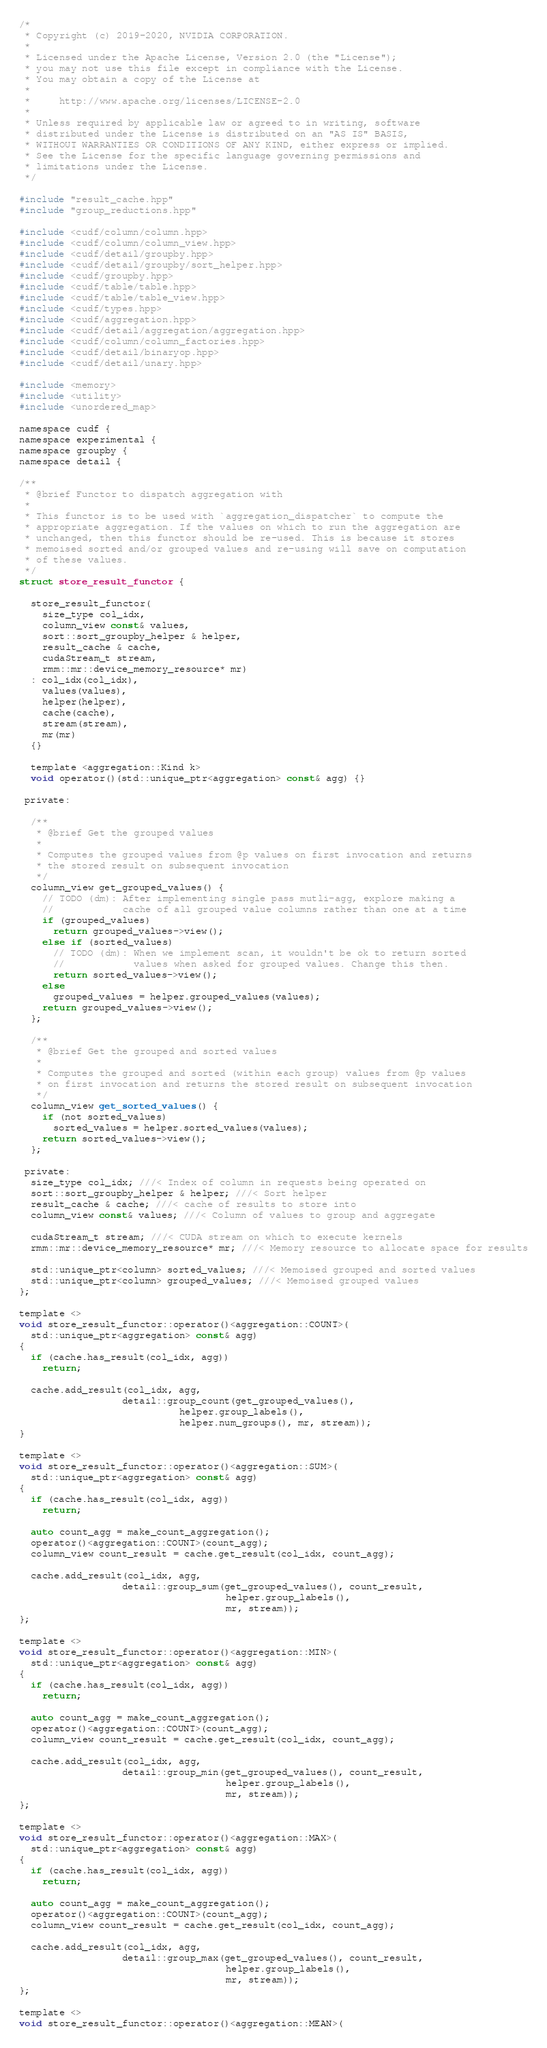Convert code to text. <code><loc_0><loc_0><loc_500><loc_500><_Cuda_>/*
 * Copyright (c) 2019-2020, NVIDIA CORPORATION.
 *
 * Licensed under the Apache License, Version 2.0 (the "License");
 * you may not use this file except in compliance with the License.
 * You may obtain a copy of the License at
 *
 *     http://www.apache.org/licenses/LICENSE-2.0
 *
 * Unless required by applicable law or agreed to in writing, software
 * distributed under the License is distributed on an "AS IS" BASIS,
 * WITHOUT WARRANTIES OR CONDITIONS OF ANY KIND, either express or implied.
 * See the License for the specific language governing permissions and
 * limitations under the License.
 */

#include "result_cache.hpp"
#include "group_reductions.hpp"

#include <cudf/column/column.hpp>
#include <cudf/column/column_view.hpp>
#include <cudf/detail/groupby.hpp>
#include <cudf/detail/groupby/sort_helper.hpp>
#include <cudf/groupby.hpp>
#include <cudf/table/table.hpp>
#include <cudf/table/table_view.hpp>
#include <cudf/types.hpp>
#include <cudf/aggregation.hpp>
#include <cudf/detail/aggregation/aggregation.hpp>
#include <cudf/column/column_factories.hpp>
#include <cudf/detail/binaryop.hpp>
#include <cudf/detail/unary.hpp>

#include <memory>
#include <utility>
#include <unordered_map>

namespace cudf {
namespace experimental {
namespace groupby {
namespace detail {

/**
 * @brief Functor to dispatch aggregation with
 * 
 * This functor is to be used with `aggregation_dispatcher` to compute the
 * appropriate aggregation. If the values on which to run the aggregation are
 * unchanged, then this functor should be re-used. This is because it stores
 * memoised sorted and/or grouped values and re-using will save on computation
 * of these values.
 */
struct store_result_functor {

  store_result_functor(
    size_type col_idx,
    column_view const& values,
    sort::sort_groupby_helper & helper,
    result_cache & cache,
    cudaStream_t stream,
    rmm::mr::device_memory_resource* mr)
  : col_idx(col_idx),
    values(values),
    helper(helper),
    cache(cache),
    stream(stream),
    mr(mr)
  {}

  template <aggregation::Kind k>
  void operator()(std::unique_ptr<aggregation> const& agg) {}

 private:

  /**
   * @brief Get the grouped values
   * 
   * Computes the grouped values from @p values on first invocation and returns
   * the stored result on subsequent invocation
   */
  column_view get_grouped_values() {
    // TODO (dm): After implementing single pass mutli-agg, explore making a
    //            cache of all grouped value columns rather than one at a time
    if (grouped_values)
      return grouped_values->view();
    else if (sorted_values)
      // TODO (dm): When we implement scan, it wouldn't be ok to return sorted
      //            values when asked for grouped values. Change this then.
      return sorted_values->view();
    else
      grouped_values = helper.grouped_values(values);
    return grouped_values->view();
  };

  /**
   * @brief Get the grouped and sorted values
   * 
   * Computes the grouped and sorted (within each group) values from @p values 
   * on first invocation and returns the stored result on subsequent invocation
   */
  column_view get_sorted_values() {
    if (not sorted_values)
      sorted_values = helper.sorted_values(values);
    return sorted_values->view();
  };

 private:
  size_type col_idx; ///< Index of column in requests being operated on
  sort::sort_groupby_helper & helper; ///< Sort helper
  result_cache & cache; ///< cache of results to store into
  column_view const& values; ///< Column of values to group and aggregate

  cudaStream_t stream; ///< CUDA stream on which to execute kernels 
  rmm::mr::device_memory_resource* mr; ///< Memory resource to allocate space for results

  std::unique_ptr<column> sorted_values; ///< Memoised grouped and sorted values
  std::unique_ptr<column> grouped_values; ///< Memoised grouped values
};

template <>
void store_result_functor::operator()<aggregation::COUNT>(
  std::unique_ptr<aggregation> const& agg)
{
  if (cache.has_result(col_idx, agg))
    return;

  cache.add_result(col_idx, agg, 
                  detail::group_count(get_grouped_values(), 
                            helper.group_labels(),
                            helper.num_groups(), mr, stream));
}

template <>
void store_result_functor::operator()<aggregation::SUM>(
  std::unique_ptr<aggregation> const& agg)
{
  if (cache.has_result(col_idx, agg))
    return;

  auto count_agg = make_count_aggregation();
  operator()<aggregation::COUNT>(count_agg);
  column_view count_result = cache.get_result(col_idx, count_agg);

  cache.add_result(col_idx, agg, 
                  detail::group_sum(get_grouped_values(), count_result, 
                                    helper.group_labels(),
                                    mr, stream));
};

template <>
void store_result_functor::operator()<aggregation::MIN>(
  std::unique_ptr<aggregation> const& agg)
{
  if (cache.has_result(col_idx, agg))
    return;

  auto count_agg = make_count_aggregation();
  operator()<aggregation::COUNT>(count_agg);
  column_view count_result = cache.get_result(col_idx, count_agg);

  cache.add_result(col_idx, agg, 
                  detail::group_min(get_grouped_values(), count_result, 
                                    helper.group_labels(),
                                    mr, stream));
};

template <>
void store_result_functor::operator()<aggregation::MAX>(
  std::unique_ptr<aggregation> const& agg)
{
  if (cache.has_result(col_idx, agg))
    return;

  auto count_agg = make_count_aggregation();
  operator()<aggregation::COUNT>(count_agg);
  column_view count_result = cache.get_result(col_idx, count_agg);

  cache.add_result(col_idx, agg, 
                  detail::group_max(get_grouped_values(), count_result, 
                                    helper.group_labels(),
                                    mr, stream));
};

template <>
void store_result_functor::operator()<aggregation::MEAN>(</code> 